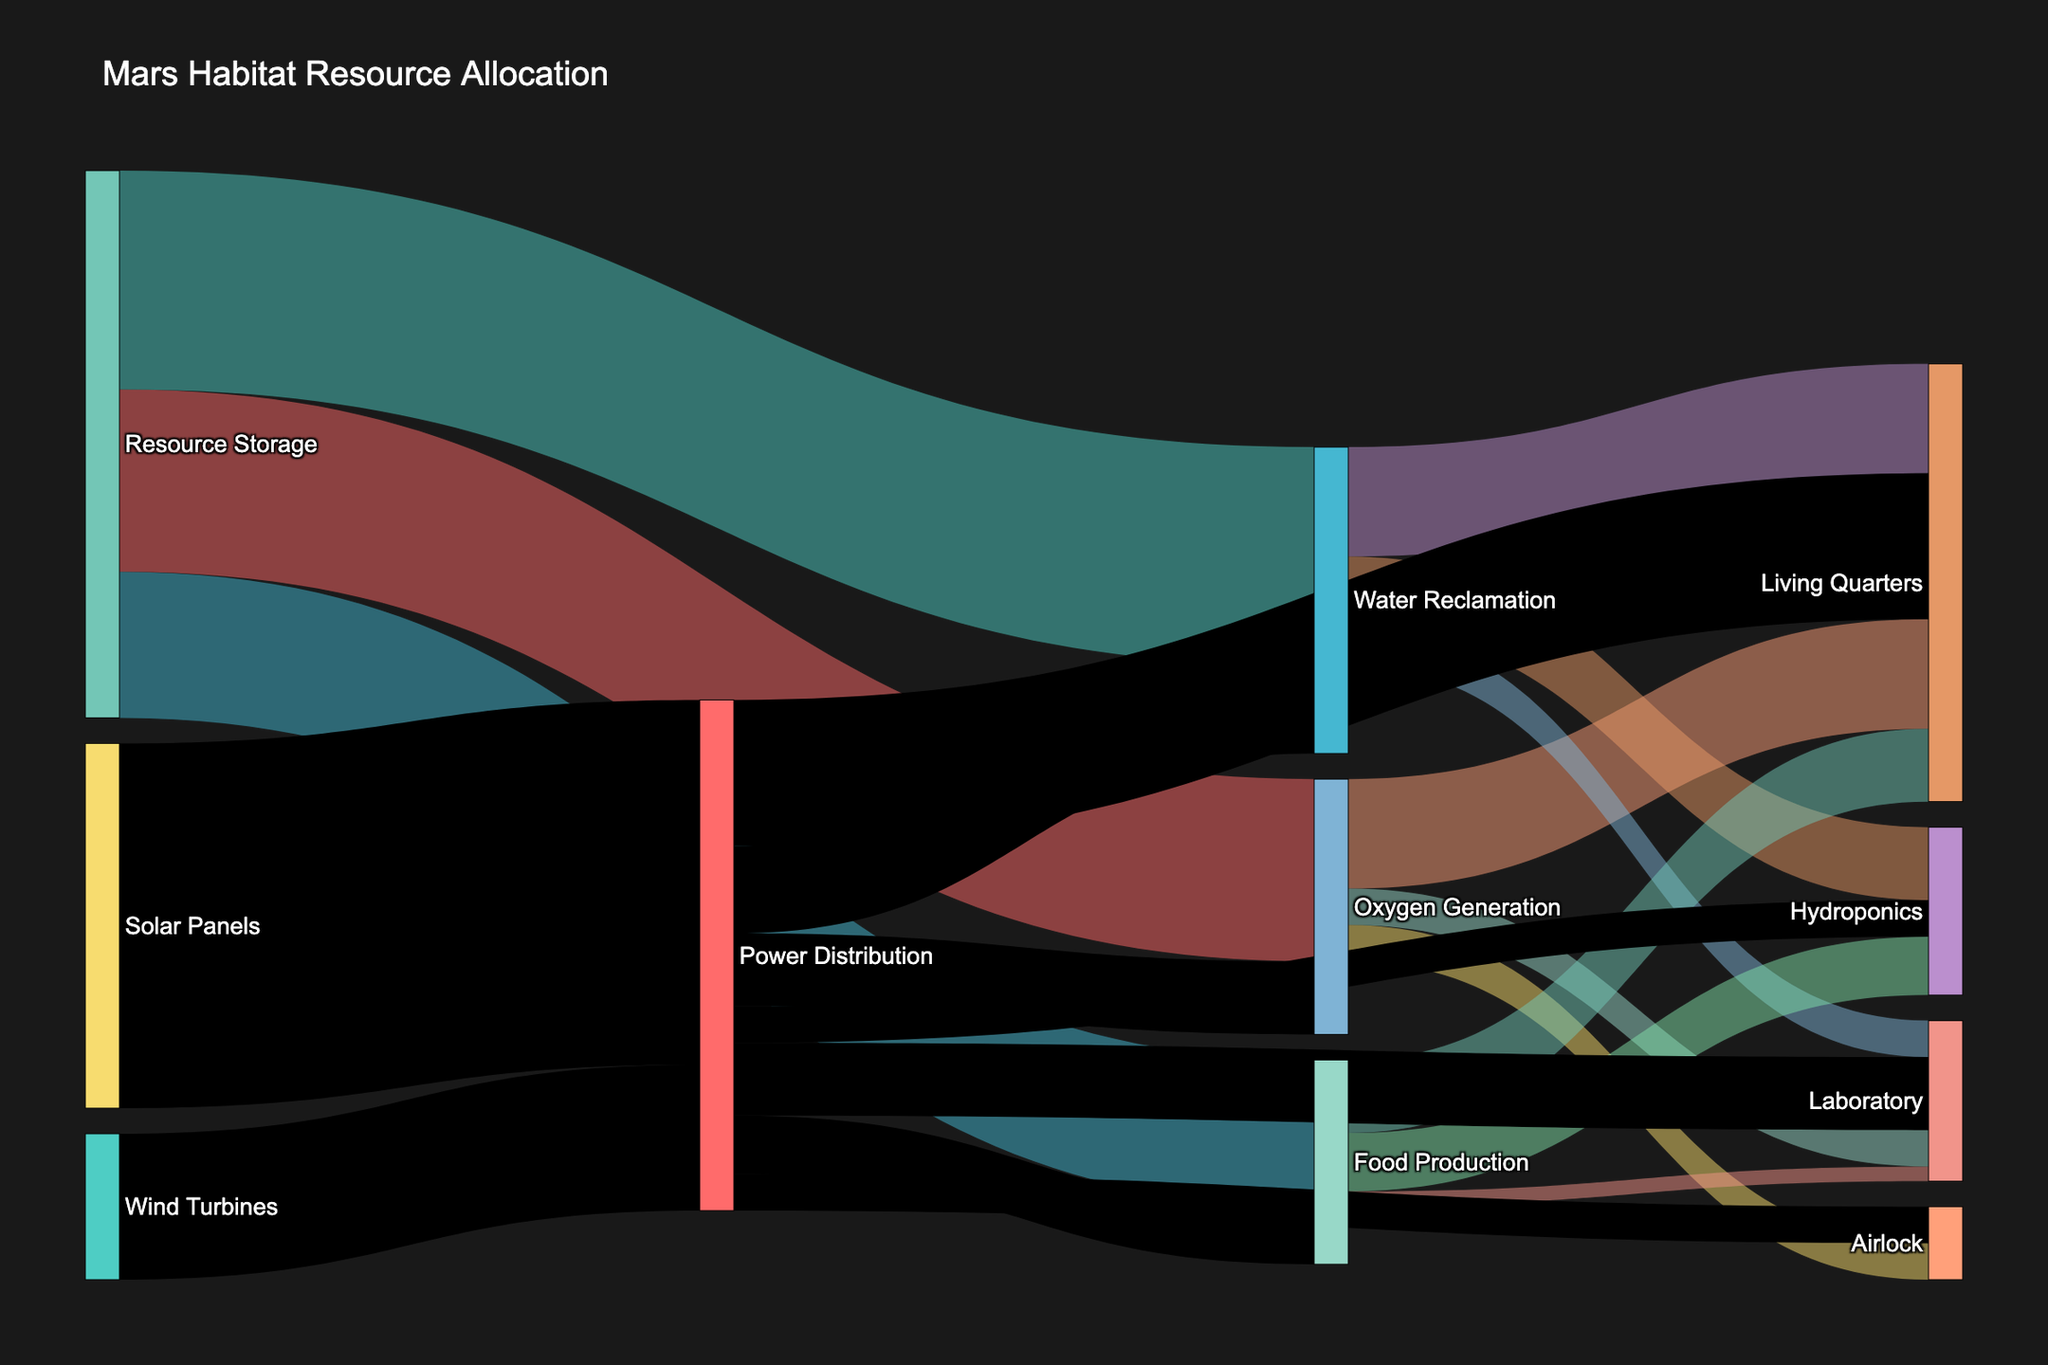Which resource receives the most allocation from Resource Storage? To identify which resource receives the most allocation from Resource Storage, look at the outgoing links from Resource Storage and compare their values. The highest value among those is 300, which goes to Water Reclamation.
Answer: Water Reclamation What is the total amount of power distributed? To find the total power distribution, sum the values of the links originating from Power Distribution: 100 (Oxygen Generation) + 120 (Water Reclamation) + 80 (Food Production) + 200 (Living Quarters) + 100 (Laboratory) + 50 (Airlock) + 50 (Hydroponics) = 700.
Answer: 700 How much more power is allocated to Living Quarters than to the Airlock? First, find the power allocated to Living Quarters (200) and the Airlock (50). The difference is 200 - 50 = 150.
Answer: 150 Which module receives both power and resources from Water Reclamation? Identify the modules receiving resources from Water Reclamation. Then check which one(s) also receive power from Power Distribution. Living Quarters gets resources from Water Reclamation (150) and power from Power Distribution (200).
Answer: Living Quarters How many unique modules are there in total? Count the unique entries in both the source and target columns. Combining and deduplicating these lists gives: Resource Storage, Oxygen Generation, Water Reclamation, Food Production, Living Quarters, Laboratory, Airlock, Hydroponics, Solar Panels, Wind Turbines, Power Distribution, resulting in 11 unique modules.
Answer: 11 Which source has the highest individual resource flow? Check the highest value in the value column of the dataset. The highest value is 500, from Solar Panels to Power Distribution.
Answer: Solar Panels Is more power allocated to Habitat-related modules or to Oxygen Generation? Sum the power going to Habitat-related modules (Living Quarters: 200, Laboratory: 100, Airlock: 50, Hydroponics: 50), which totals 400. Compare it with the power allocated to Oxygen Generation, which is 100. 400 is greater than 100.
Answer: Habitat-related modules What is the combined resource allocation to Hydroponics? Identify and sum the values of all resources going to Hydroponics: From Water Reclamation (100) and Food Production (80). The total is 100 + 80 = 180.
Answer: 180 